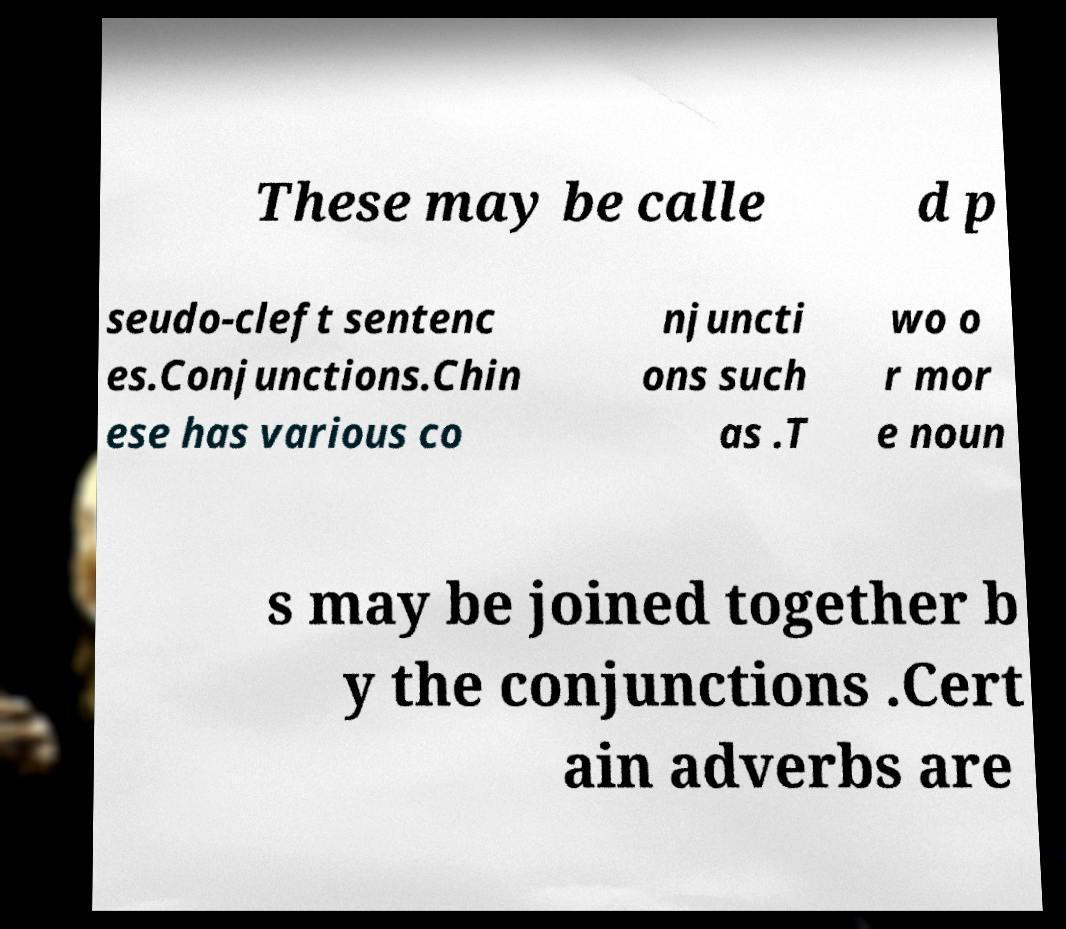What messages or text are displayed in this image? I need them in a readable, typed format. These may be calle d p seudo-cleft sentenc es.Conjunctions.Chin ese has various co njuncti ons such as .T wo o r mor e noun s may be joined together b y the conjunctions .Cert ain adverbs are 